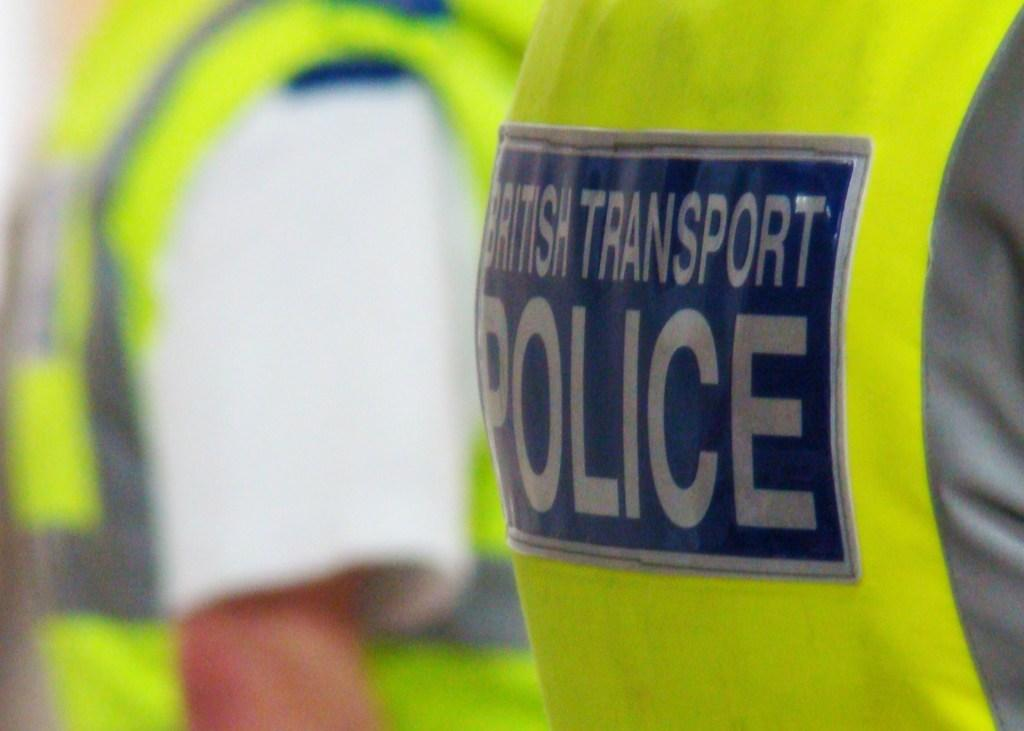Provide a one-sentence caption for the provided image. The hi visibility yellow vest worn by a British Transport police. 